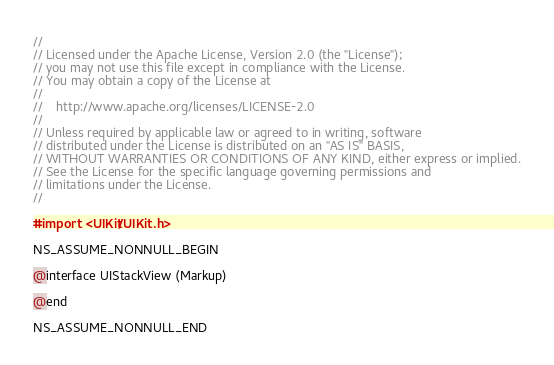<code> <loc_0><loc_0><loc_500><loc_500><_C_>//
// Licensed under the Apache License, Version 2.0 (the "License");
// you may not use this file except in compliance with the License.
// You may obtain a copy of the License at
//
//    http://www.apache.org/licenses/LICENSE-2.0
//
// Unless required by applicable law or agreed to in writing, software
// distributed under the License is distributed on an "AS IS" BASIS,
// WITHOUT WARRANTIES OR CONDITIONS OF ANY KIND, either express or implied.
// See the License for the specific language governing permissions and
// limitations under the License.
//

#import <UIKit/UIKit.h>

NS_ASSUME_NONNULL_BEGIN

@interface UIStackView (Markup)

@end

NS_ASSUME_NONNULL_END
</code> 